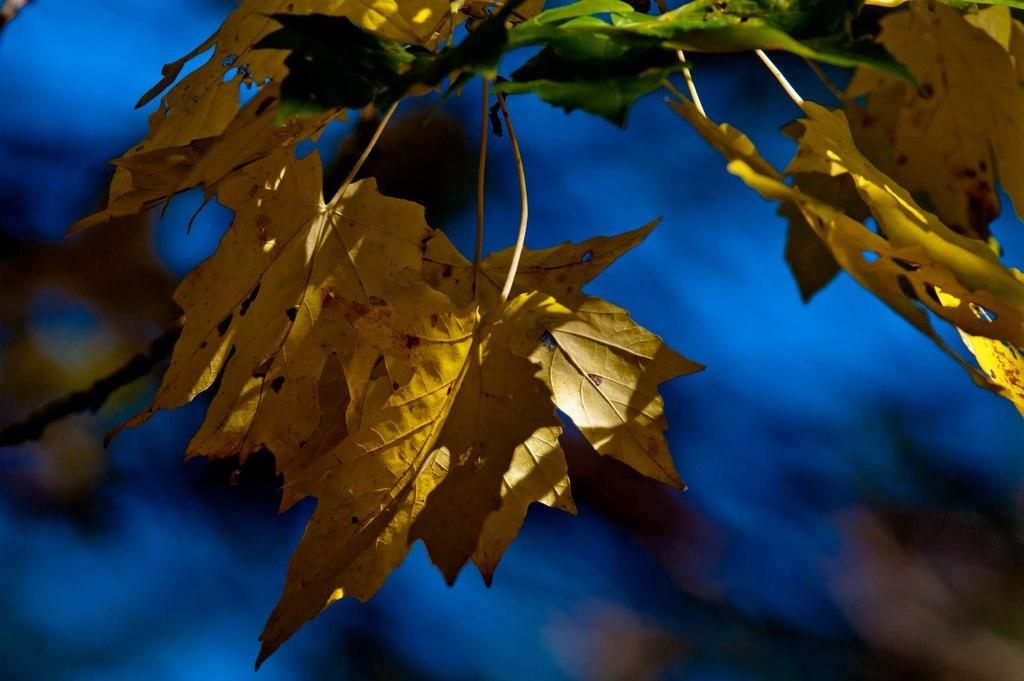What type of plant parts can be seen in the image? There are leaves and stems in the image. What can be observed about the background of the image? The background of the image is blurred. What color is present in the image? There is a blue color visible in the image. Can you tell me how many feathers are present in the image? There are no feathers present in the image; it features leaves and stems. What part of the brain can be seen in the image? There is no brain visible in the image; it features leaves and stems. 